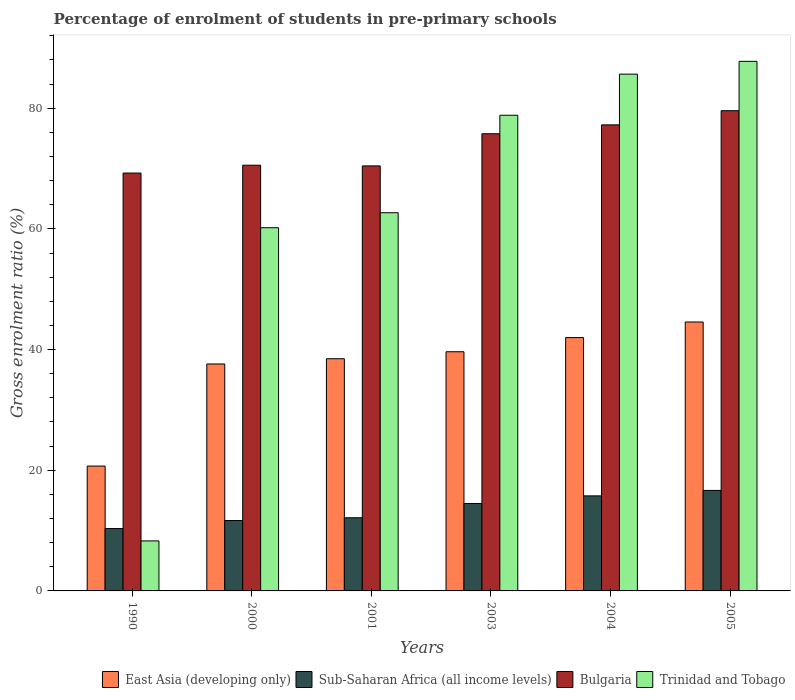How many different coloured bars are there?
Offer a terse response. 4. Are the number of bars on each tick of the X-axis equal?
Give a very brief answer. Yes. How many bars are there on the 3rd tick from the left?
Offer a terse response. 4. How many bars are there on the 3rd tick from the right?
Offer a terse response. 4. What is the label of the 4th group of bars from the left?
Make the answer very short. 2003. What is the percentage of students enrolled in pre-primary schools in Bulgaria in 2000?
Keep it short and to the point. 70.55. Across all years, what is the maximum percentage of students enrolled in pre-primary schools in East Asia (developing only)?
Give a very brief answer. 44.57. Across all years, what is the minimum percentage of students enrolled in pre-primary schools in East Asia (developing only)?
Your response must be concise. 20.69. In which year was the percentage of students enrolled in pre-primary schools in Bulgaria maximum?
Your answer should be very brief. 2005. In which year was the percentage of students enrolled in pre-primary schools in Bulgaria minimum?
Make the answer very short. 1990. What is the total percentage of students enrolled in pre-primary schools in East Asia (developing only) in the graph?
Keep it short and to the point. 222.98. What is the difference between the percentage of students enrolled in pre-primary schools in Sub-Saharan Africa (all income levels) in 1990 and that in 2000?
Give a very brief answer. -1.33. What is the difference between the percentage of students enrolled in pre-primary schools in East Asia (developing only) in 2005 and the percentage of students enrolled in pre-primary schools in Bulgaria in 2003?
Give a very brief answer. -31.2. What is the average percentage of students enrolled in pre-primary schools in Trinidad and Tobago per year?
Provide a short and direct response. 63.9. In the year 2003, what is the difference between the percentage of students enrolled in pre-primary schools in East Asia (developing only) and percentage of students enrolled in pre-primary schools in Trinidad and Tobago?
Offer a very short reply. -39.2. In how many years, is the percentage of students enrolled in pre-primary schools in Trinidad and Tobago greater than 36 %?
Your answer should be compact. 5. What is the ratio of the percentage of students enrolled in pre-primary schools in Sub-Saharan Africa (all income levels) in 1990 to that in 2001?
Keep it short and to the point. 0.85. Is the difference between the percentage of students enrolled in pre-primary schools in East Asia (developing only) in 1990 and 2003 greater than the difference between the percentage of students enrolled in pre-primary schools in Trinidad and Tobago in 1990 and 2003?
Provide a short and direct response. Yes. What is the difference between the highest and the second highest percentage of students enrolled in pre-primary schools in East Asia (developing only)?
Give a very brief answer. 2.58. What is the difference between the highest and the lowest percentage of students enrolled in pre-primary schools in Sub-Saharan Africa (all income levels)?
Provide a succinct answer. 6.32. In how many years, is the percentage of students enrolled in pre-primary schools in Bulgaria greater than the average percentage of students enrolled in pre-primary schools in Bulgaria taken over all years?
Keep it short and to the point. 3. Is it the case that in every year, the sum of the percentage of students enrolled in pre-primary schools in Trinidad and Tobago and percentage of students enrolled in pre-primary schools in East Asia (developing only) is greater than the sum of percentage of students enrolled in pre-primary schools in Bulgaria and percentage of students enrolled in pre-primary schools in Sub-Saharan Africa (all income levels)?
Make the answer very short. No. What does the 1st bar from the left in 2003 represents?
Give a very brief answer. East Asia (developing only). What does the 3rd bar from the right in 2005 represents?
Your answer should be very brief. Sub-Saharan Africa (all income levels). How many bars are there?
Your answer should be very brief. 24. Are all the bars in the graph horizontal?
Offer a very short reply. No. How many years are there in the graph?
Make the answer very short. 6. What is the difference between two consecutive major ticks on the Y-axis?
Give a very brief answer. 20. Are the values on the major ticks of Y-axis written in scientific E-notation?
Your answer should be compact. No. Where does the legend appear in the graph?
Provide a short and direct response. Bottom right. How many legend labels are there?
Make the answer very short. 4. What is the title of the graph?
Your answer should be compact. Percentage of enrolment of students in pre-primary schools. Does "Finland" appear as one of the legend labels in the graph?
Ensure brevity in your answer.  No. What is the Gross enrolment ratio (%) of East Asia (developing only) in 1990?
Give a very brief answer. 20.69. What is the Gross enrolment ratio (%) in Sub-Saharan Africa (all income levels) in 1990?
Ensure brevity in your answer.  10.34. What is the Gross enrolment ratio (%) in Bulgaria in 1990?
Ensure brevity in your answer.  69.25. What is the Gross enrolment ratio (%) of Trinidad and Tobago in 1990?
Offer a very short reply. 8.29. What is the Gross enrolment ratio (%) of East Asia (developing only) in 2000?
Keep it short and to the point. 37.61. What is the Gross enrolment ratio (%) of Sub-Saharan Africa (all income levels) in 2000?
Your response must be concise. 11.67. What is the Gross enrolment ratio (%) of Bulgaria in 2000?
Your answer should be compact. 70.55. What is the Gross enrolment ratio (%) of Trinidad and Tobago in 2000?
Give a very brief answer. 60.19. What is the Gross enrolment ratio (%) in East Asia (developing only) in 2001?
Offer a very short reply. 38.48. What is the Gross enrolment ratio (%) in Sub-Saharan Africa (all income levels) in 2001?
Keep it short and to the point. 12.13. What is the Gross enrolment ratio (%) of Bulgaria in 2001?
Keep it short and to the point. 70.44. What is the Gross enrolment ratio (%) of Trinidad and Tobago in 2001?
Provide a short and direct response. 62.68. What is the Gross enrolment ratio (%) of East Asia (developing only) in 2003?
Offer a terse response. 39.64. What is the Gross enrolment ratio (%) of Sub-Saharan Africa (all income levels) in 2003?
Provide a succinct answer. 14.49. What is the Gross enrolment ratio (%) in Bulgaria in 2003?
Your answer should be very brief. 75.77. What is the Gross enrolment ratio (%) in Trinidad and Tobago in 2003?
Provide a succinct answer. 78.84. What is the Gross enrolment ratio (%) of East Asia (developing only) in 2004?
Provide a short and direct response. 41.99. What is the Gross enrolment ratio (%) of Sub-Saharan Africa (all income levels) in 2004?
Provide a short and direct response. 15.75. What is the Gross enrolment ratio (%) of Bulgaria in 2004?
Offer a very short reply. 77.24. What is the Gross enrolment ratio (%) in Trinidad and Tobago in 2004?
Provide a short and direct response. 85.65. What is the Gross enrolment ratio (%) of East Asia (developing only) in 2005?
Your answer should be very brief. 44.57. What is the Gross enrolment ratio (%) in Sub-Saharan Africa (all income levels) in 2005?
Your response must be concise. 16.66. What is the Gross enrolment ratio (%) in Bulgaria in 2005?
Ensure brevity in your answer.  79.59. What is the Gross enrolment ratio (%) in Trinidad and Tobago in 2005?
Keep it short and to the point. 87.77. Across all years, what is the maximum Gross enrolment ratio (%) in East Asia (developing only)?
Make the answer very short. 44.57. Across all years, what is the maximum Gross enrolment ratio (%) of Sub-Saharan Africa (all income levels)?
Keep it short and to the point. 16.66. Across all years, what is the maximum Gross enrolment ratio (%) of Bulgaria?
Offer a terse response. 79.59. Across all years, what is the maximum Gross enrolment ratio (%) of Trinidad and Tobago?
Ensure brevity in your answer.  87.77. Across all years, what is the minimum Gross enrolment ratio (%) in East Asia (developing only)?
Offer a very short reply. 20.69. Across all years, what is the minimum Gross enrolment ratio (%) of Sub-Saharan Africa (all income levels)?
Keep it short and to the point. 10.34. Across all years, what is the minimum Gross enrolment ratio (%) of Bulgaria?
Offer a very short reply. 69.25. Across all years, what is the minimum Gross enrolment ratio (%) in Trinidad and Tobago?
Your answer should be very brief. 8.29. What is the total Gross enrolment ratio (%) in East Asia (developing only) in the graph?
Keep it short and to the point. 222.98. What is the total Gross enrolment ratio (%) in Sub-Saharan Africa (all income levels) in the graph?
Provide a succinct answer. 81.02. What is the total Gross enrolment ratio (%) of Bulgaria in the graph?
Make the answer very short. 442.85. What is the total Gross enrolment ratio (%) in Trinidad and Tobago in the graph?
Ensure brevity in your answer.  383.41. What is the difference between the Gross enrolment ratio (%) of East Asia (developing only) in 1990 and that in 2000?
Offer a very short reply. -16.92. What is the difference between the Gross enrolment ratio (%) of Sub-Saharan Africa (all income levels) in 1990 and that in 2000?
Provide a succinct answer. -1.33. What is the difference between the Gross enrolment ratio (%) in Trinidad and Tobago in 1990 and that in 2000?
Ensure brevity in your answer.  -51.91. What is the difference between the Gross enrolment ratio (%) in East Asia (developing only) in 1990 and that in 2001?
Provide a short and direct response. -17.79. What is the difference between the Gross enrolment ratio (%) of Sub-Saharan Africa (all income levels) in 1990 and that in 2001?
Provide a succinct answer. -1.79. What is the difference between the Gross enrolment ratio (%) of Bulgaria in 1990 and that in 2001?
Offer a terse response. -1.19. What is the difference between the Gross enrolment ratio (%) in Trinidad and Tobago in 1990 and that in 2001?
Ensure brevity in your answer.  -54.39. What is the difference between the Gross enrolment ratio (%) of East Asia (developing only) in 1990 and that in 2003?
Provide a succinct answer. -18.95. What is the difference between the Gross enrolment ratio (%) in Sub-Saharan Africa (all income levels) in 1990 and that in 2003?
Ensure brevity in your answer.  -4.15. What is the difference between the Gross enrolment ratio (%) of Bulgaria in 1990 and that in 2003?
Make the answer very short. -6.52. What is the difference between the Gross enrolment ratio (%) of Trinidad and Tobago in 1990 and that in 2003?
Keep it short and to the point. -70.55. What is the difference between the Gross enrolment ratio (%) of East Asia (developing only) in 1990 and that in 2004?
Provide a short and direct response. -21.29. What is the difference between the Gross enrolment ratio (%) of Sub-Saharan Africa (all income levels) in 1990 and that in 2004?
Your response must be concise. -5.42. What is the difference between the Gross enrolment ratio (%) in Bulgaria in 1990 and that in 2004?
Your response must be concise. -7.99. What is the difference between the Gross enrolment ratio (%) in Trinidad and Tobago in 1990 and that in 2004?
Provide a short and direct response. -77.36. What is the difference between the Gross enrolment ratio (%) of East Asia (developing only) in 1990 and that in 2005?
Your answer should be compact. -23.88. What is the difference between the Gross enrolment ratio (%) of Sub-Saharan Africa (all income levels) in 1990 and that in 2005?
Provide a succinct answer. -6.32. What is the difference between the Gross enrolment ratio (%) of Bulgaria in 1990 and that in 2005?
Provide a short and direct response. -10.34. What is the difference between the Gross enrolment ratio (%) of Trinidad and Tobago in 1990 and that in 2005?
Make the answer very short. -79.48. What is the difference between the Gross enrolment ratio (%) in East Asia (developing only) in 2000 and that in 2001?
Offer a terse response. -0.87. What is the difference between the Gross enrolment ratio (%) of Sub-Saharan Africa (all income levels) in 2000 and that in 2001?
Keep it short and to the point. -0.46. What is the difference between the Gross enrolment ratio (%) of Bulgaria in 2000 and that in 2001?
Provide a short and direct response. 0.11. What is the difference between the Gross enrolment ratio (%) in Trinidad and Tobago in 2000 and that in 2001?
Your response must be concise. -2.48. What is the difference between the Gross enrolment ratio (%) of East Asia (developing only) in 2000 and that in 2003?
Your answer should be compact. -2.03. What is the difference between the Gross enrolment ratio (%) in Sub-Saharan Africa (all income levels) in 2000 and that in 2003?
Give a very brief answer. -2.82. What is the difference between the Gross enrolment ratio (%) in Bulgaria in 2000 and that in 2003?
Your answer should be compact. -5.22. What is the difference between the Gross enrolment ratio (%) of Trinidad and Tobago in 2000 and that in 2003?
Offer a terse response. -18.64. What is the difference between the Gross enrolment ratio (%) of East Asia (developing only) in 2000 and that in 2004?
Your answer should be compact. -4.37. What is the difference between the Gross enrolment ratio (%) of Sub-Saharan Africa (all income levels) in 2000 and that in 2004?
Give a very brief answer. -4.09. What is the difference between the Gross enrolment ratio (%) of Bulgaria in 2000 and that in 2004?
Make the answer very short. -6.69. What is the difference between the Gross enrolment ratio (%) in Trinidad and Tobago in 2000 and that in 2004?
Offer a terse response. -25.45. What is the difference between the Gross enrolment ratio (%) in East Asia (developing only) in 2000 and that in 2005?
Provide a succinct answer. -6.96. What is the difference between the Gross enrolment ratio (%) in Sub-Saharan Africa (all income levels) in 2000 and that in 2005?
Your response must be concise. -4.99. What is the difference between the Gross enrolment ratio (%) of Bulgaria in 2000 and that in 2005?
Your answer should be compact. -9.04. What is the difference between the Gross enrolment ratio (%) in Trinidad and Tobago in 2000 and that in 2005?
Your answer should be compact. -27.57. What is the difference between the Gross enrolment ratio (%) of East Asia (developing only) in 2001 and that in 2003?
Ensure brevity in your answer.  -1.16. What is the difference between the Gross enrolment ratio (%) of Sub-Saharan Africa (all income levels) in 2001 and that in 2003?
Offer a very short reply. -2.36. What is the difference between the Gross enrolment ratio (%) of Bulgaria in 2001 and that in 2003?
Your answer should be compact. -5.33. What is the difference between the Gross enrolment ratio (%) of Trinidad and Tobago in 2001 and that in 2003?
Provide a short and direct response. -16.16. What is the difference between the Gross enrolment ratio (%) of East Asia (developing only) in 2001 and that in 2004?
Your answer should be compact. -3.5. What is the difference between the Gross enrolment ratio (%) in Sub-Saharan Africa (all income levels) in 2001 and that in 2004?
Offer a very short reply. -3.63. What is the difference between the Gross enrolment ratio (%) of Bulgaria in 2001 and that in 2004?
Ensure brevity in your answer.  -6.8. What is the difference between the Gross enrolment ratio (%) of Trinidad and Tobago in 2001 and that in 2004?
Offer a terse response. -22.97. What is the difference between the Gross enrolment ratio (%) of East Asia (developing only) in 2001 and that in 2005?
Provide a succinct answer. -6.09. What is the difference between the Gross enrolment ratio (%) in Sub-Saharan Africa (all income levels) in 2001 and that in 2005?
Ensure brevity in your answer.  -4.53. What is the difference between the Gross enrolment ratio (%) of Bulgaria in 2001 and that in 2005?
Keep it short and to the point. -9.15. What is the difference between the Gross enrolment ratio (%) in Trinidad and Tobago in 2001 and that in 2005?
Offer a terse response. -25.09. What is the difference between the Gross enrolment ratio (%) in East Asia (developing only) in 2003 and that in 2004?
Make the answer very short. -2.35. What is the difference between the Gross enrolment ratio (%) of Sub-Saharan Africa (all income levels) in 2003 and that in 2004?
Provide a succinct answer. -1.27. What is the difference between the Gross enrolment ratio (%) in Bulgaria in 2003 and that in 2004?
Give a very brief answer. -1.47. What is the difference between the Gross enrolment ratio (%) of Trinidad and Tobago in 2003 and that in 2004?
Your answer should be compact. -6.81. What is the difference between the Gross enrolment ratio (%) of East Asia (developing only) in 2003 and that in 2005?
Provide a short and direct response. -4.93. What is the difference between the Gross enrolment ratio (%) in Sub-Saharan Africa (all income levels) in 2003 and that in 2005?
Make the answer very short. -2.17. What is the difference between the Gross enrolment ratio (%) of Bulgaria in 2003 and that in 2005?
Provide a short and direct response. -3.82. What is the difference between the Gross enrolment ratio (%) of Trinidad and Tobago in 2003 and that in 2005?
Offer a very short reply. -8.93. What is the difference between the Gross enrolment ratio (%) in East Asia (developing only) in 2004 and that in 2005?
Keep it short and to the point. -2.58. What is the difference between the Gross enrolment ratio (%) in Sub-Saharan Africa (all income levels) in 2004 and that in 2005?
Provide a short and direct response. -0.9. What is the difference between the Gross enrolment ratio (%) of Bulgaria in 2004 and that in 2005?
Give a very brief answer. -2.35. What is the difference between the Gross enrolment ratio (%) in Trinidad and Tobago in 2004 and that in 2005?
Ensure brevity in your answer.  -2.12. What is the difference between the Gross enrolment ratio (%) in East Asia (developing only) in 1990 and the Gross enrolment ratio (%) in Sub-Saharan Africa (all income levels) in 2000?
Provide a succinct answer. 9.03. What is the difference between the Gross enrolment ratio (%) of East Asia (developing only) in 1990 and the Gross enrolment ratio (%) of Bulgaria in 2000?
Your response must be concise. -49.86. What is the difference between the Gross enrolment ratio (%) of East Asia (developing only) in 1990 and the Gross enrolment ratio (%) of Trinidad and Tobago in 2000?
Make the answer very short. -39.5. What is the difference between the Gross enrolment ratio (%) of Sub-Saharan Africa (all income levels) in 1990 and the Gross enrolment ratio (%) of Bulgaria in 2000?
Make the answer very short. -60.22. What is the difference between the Gross enrolment ratio (%) of Sub-Saharan Africa (all income levels) in 1990 and the Gross enrolment ratio (%) of Trinidad and Tobago in 2000?
Your response must be concise. -49.86. What is the difference between the Gross enrolment ratio (%) of Bulgaria in 1990 and the Gross enrolment ratio (%) of Trinidad and Tobago in 2000?
Offer a very short reply. 9.06. What is the difference between the Gross enrolment ratio (%) of East Asia (developing only) in 1990 and the Gross enrolment ratio (%) of Sub-Saharan Africa (all income levels) in 2001?
Make the answer very short. 8.57. What is the difference between the Gross enrolment ratio (%) in East Asia (developing only) in 1990 and the Gross enrolment ratio (%) in Bulgaria in 2001?
Your response must be concise. -49.75. What is the difference between the Gross enrolment ratio (%) of East Asia (developing only) in 1990 and the Gross enrolment ratio (%) of Trinidad and Tobago in 2001?
Keep it short and to the point. -41.99. What is the difference between the Gross enrolment ratio (%) of Sub-Saharan Africa (all income levels) in 1990 and the Gross enrolment ratio (%) of Bulgaria in 2001?
Your answer should be compact. -60.1. What is the difference between the Gross enrolment ratio (%) in Sub-Saharan Africa (all income levels) in 1990 and the Gross enrolment ratio (%) in Trinidad and Tobago in 2001?
Offer a terse response. -52.34. What is the difference between the Gross enrolment ratio (%) of Bulgaria in 1990 and the Gross enrolment ratio (%) of Trinidad and Tobago in 2001?
Make the answer very short. 6.57. What is the difference between the Gross enrolment ratio (%) in East Asia (developing only) in 1990 and the Gross enrolment ratio (%) in Sub-Saharan Africa (all income levels) in 2003?
Offer a terse response. 6.21. What is the difference between the Gross enrolment ratio (%) in East Asia (developing only) in 1990 and the Gross enrolment ratio (%) in Bulgaria in 2003?
Keep it short and to the point. -55.08. What is the difference between the Gross enrolment ratio (%) in East Asia (developing only) in 1990 and the Gross enrolment ratio (%) in Trinidad and Tobago in 2003?
Your response must be concise. -58.14. What is the difference between the Gross enrolment ratio (%) of Sub-Saharan Africa (all income levels) in 1990 and the Gross enrolment ratio (%) of Bulgaria in 2003?
Ensure brevity in your answer.  -65.43. What is the difference between the Gross enrolment ratio (%) in Sub-Saharan Africa (all income levels) in 1990 and the Gross enrolment ratio (%) in Trinidad and Tobago in 2003?
Your answer should be compact. -68.5. What is the difference between the Gross enrolment ratio (%) in Bulgaria in 1990 and the Gross enrolment ratio (%) in Trinidad and Tobago in 2003?
Your answer should be very brief. -9.58. What is the difference between the Gross enrolment ratio (%) of East Asia (developing only) in 1990 and the Gross enrolment ratio (%) of Sub-Saharan Africa (all income levels) in 2004?
Keep it short and to the point. 4.94. What is the difference between the Gross enrolment ratio (%) in East Asia (developing only) in 1990 and the Gross enrolment ratio (%) in Bulgaria in 2004?
Your response must be concise. -56.55. What is the difference between the Gross enrolment ratio (%) in East Asia (developing only) in 1990 and the Gross enrolment ratio (%) in Trinidad and Tobago in 2004?
Give a very brief answer. -64.96. What is the difference between the Gross enrolment ratio (%) of Sub-Saharan Africa (all income levels) in 1990 and the Gross enrolment ratio (%) of Bulgaria in 2004?
Provide a succinct answer. -66.91. What is the difference between the Gross enrolment ratio (%) of Sub-Saharan Africa (all income levels) in 1990 and the Gross enrolment ratio (%) of Trinidad and Tobago in 2004?
Make the answer very short. -75.31. What is the difference between the Gross enrolment ratio (%) in Bulgaria in 1990 and the Gross enrolment ratio (%) in Trinidad and Tobago in 2004?
Offer a very short reply. -16.4. What is the difference between the Gross enrolment ratio (%) in East Asia (developing only) in 1990 and the Gross enrolment ratio (%) in Sub-Saharan Africa (all income levels) in 2005?
Offer a terse response. 4.04. What is the difference between the Gross enrolment ratio (%) in East Asia (developing only) in 1990 and the Gross enrolment ratio (%) in Bulgaria in 2005?
Give a very brief answer. -58.9. What is the difference between the Gross enrolment ratio (%) in East Asia (developing only) in 1990 and the Gross enrolment ratio (%) in Trinidad and Tobago in 2005?
Keep it short and to the point. -67.08. What is the difference between the Gross enrolment ratio (%) in Sub-Saharan Africa (all income levels) in 1990 and the Gross enrolment ratio (%) in Bulgaria in 2005?
Give a very brief answer. -69.25. What is the difference between the Gross enrolment ratio (%) in Sub-Saharan Africa (all income levels) in 1990 and the Gross enrolment ratio (%) in Trinidad and Tobago in 2005?
Provide a short and direct response. -77.43. What is the difference between the Gross enrolment ratio (%) in Bulgaria in 1990 and the Gross enrolment ratio (%) in Trinidad and Tobago in 2005?
Your answer should be compact. -18.51. What is the difference between the Gross enrolment ratio (%) in East Asia (developing only) in 2000 and the Gross enrolment ratio (%) in Sub-Saharan Africa (all income levels) in 2001?
Keep it short and to the point. 25.49. What is the difference between the Gross enrolment ratio (%) in East Asia (developing only) in 2000 and the Gross enrolment ratio (%) in Bulgaria in 2001?
Provide a succinct answer. -32.83. What is the difference between the Gross enrolment ratio (%) of East Asia (developing only) in 2000 and the Gross enrolment ratio (%) of Trinidad and Tobago in 2001?
Keep it short and to the point. -25.07. What is the difference between the Gross enrolment ratio (%) in Sub-Saharan Africa (all income levels) in 2000 and the Gross enrolment ratio (%) in Bulgaria in 2001?
Make the answer very short. -58.77. What is the difference between the Gross enrolment ratio (%) in Sub-Saharan Africa (all income levels) in 2000 and the Gross enrolment ratio (%) in Trinidad and Tobago in 2001?
Give a very brief answer. -51.01. What is the difference between the Gross enrolment ratio (%) in Bulgaria in 2000 and the Gross enrolment ratio (%) in Trinidad and Tobago in 2001?
Your answer should be very brief. 7.87. What is the difference between the Gross enrolment ratio (%) of East Asia (developing only) in 2000 and the Gross enrolment ratio (%) of Sub-Saharan Africa (all income levels) in 2003?
Make the answer very short. 23.13. What is the difference between the Gross enrolment ratio (%) of East Asia (developing only) in 2000 and the Gross enrolment ratio (%) of Bulgaria in 2003?
Ensure brevity in your answer.  -38.16. What is the difference between the Gross enrolment ratio (%) in East Asia (developing only) in 2000 and the Gross enrolment ratio (%) in Trinidad and Tobago in 2003?
Make the answer very short. -41.22. What is the difference between the Gross enrolment ratio (%) of Sub-Saharan Africa (all income levels) in 2000 and the Gross enrolment ratio (%) of Bulgaria in 2003?
Ensure brevity in your answer.  -64.1. What is the difference between the Gross enrolment ratio (%) of Sub-Saharan Africa (all income levels) in 2000 and the Gross enrolment ratio (%) of Trinidad and Tobago in 2003?
Offer a terse response. -67.17. What is the difference between the Gross enrolment ratio (%) in Bulgaria in 2000 and the Gross enrolment ratio (%) in Trinidad and Tobago in 2003?
Your response must be concise. -8.28. What is the difference between the Gross enrolment ratio (%) of East Asia (developing only) in 2000 and the Gross enrolment ratio (%) of Sub-Saharan Africa (all income levels) in 2004?
Your response must be concise. 21.86. What is the difference between the Gross enrolment ratio (%) of East Asia (developing only) in 2000 and the Gross enrolment ratio (%) of Bulgaria in 2004?
Your response must be concise. -39.63. What is the difference between the Gross enrolment ratio (%) in East Asia (developing only) in 2000 and the Gross enrolment ratio (%) in Trinidad and Tobago in 2004?
Provide a succinct answer. -48.04. What is the difference between the Gross enrolment ratio (%) of Sub-Saharan Africa (all income levels) in 2000 and the Gross enrolment ratio (%) of Bulgaria in 2004?
Your answer should be very brief. -65.57. What is the difference between the Gross enrolment ratio (%) of Sub-Saharan Africa (all income levels) in 2000 and the Gross enrolment ratio (%) of Trinidad and Tobago in 2004?
Keep it short and to the point. -73.98. What is the difference between the Gross enrolment ratio (%) in Bulgaria in 2000 and the Gross enrolment ratio (%) in Trinidad and Tobago in 2004?
Your answer should be compact. -15.1. What is the difference between the Gross enrolment ratio (%) of East Asia (developing only) in 2000 and the Gross enrolment ratio (%) of Sub-Saharan Africa (all income levels) in 2005?
Ensure brevity in your answer.  20.96. What is the difference between the Gross enrolment ratio (%) in East Asia (developing only) in 2000 and the Gross enrolment ratio (%) in Bulgaria in 2005?
Ensure brevity in your answer.  -41.98. What is the difference between the Gross enrolment ratio (%) of East Asia (developing only) in 2000 and the Gross enrolment ratio (%) of Trinidad and Tobago in 2005?
Your answer should be compact. -50.16. What is the difference between the Gross enrolment ratio (%) of Sub-Saharan Africa (all income levels) in 2000 and the Gross enrolment ratio (%) of Bulgaria in 2005?
Give a very brief answer. -67.92. What is the difference between the Gross enrolment ratio (%) in Sub-Saharan Africa (all income levels) in 2000 and the Gross enrolment ratio (%) in Trinidad and Tobago in 2005?
Provide a short and direct response. -76.1. What is the difference between the Gross enrolment ratio (%) in Bulgaria in 2000 and the Gross enrolment ratio (%) in Trinidad and Tobago in 2005?
Give a very brief answer. -17.21. What is the difference between the Gross enrolment ratio (%) in East Asia (developing only) in 2001 and the Gross enrolment ratio (%) in Sub-Saharan Africa (all income levels) in 2003?
Offer a very short reply. 24. What is the difference between the Gross enrolment ratio (%) of East Asia (developing only) in 2001 and the Gross enrolment ratio (%) of Bulgaria in 2003?
Offer a very short reply. -37.29. What is the difference between the Gross enrolment ratio (%) of East Asia (developing only) in 2001 and the Gross enrolment ratio (%) of Trinidad and Tobago in 2003?
Give a very brief answer. -40.35. What is the difference between the Gross enrolment ratio (%) in Sub-Saharan Africa (all income levels) in 2001 and the Gross enrolment ratio (%) in Bulgaria in 2003?
Your answer should be compact. -63.64. What is the difference between the Gross enrolment ratio (%) in Sub-Saharan Africa (all income levels) in 2001 and the Gross enrolment ratio (%) in Trinidad and Tobago in 2003?
Your answer should be very brief. -66.71. What is the difference between the Gross enrolment ratio (%) in Bulgaria in 2001 and the Gross enrolment ratio (%) in Trinidad and Tobago in 2003?
Offer a terse response. -8.4. What is the difference between the Gross enrolment ratio (%) of East Asia (developing only) in 2001 and the Gross enrolment ratio (%) of Sub-Saharan Africa (all income levels) in 2004?
Give a very brief answer. 22.73. What is the difference between the Gross enrolment ratio (%) of East Asia (developing only) in 2001 and the Gross enrolment ratio (%) of Bulgaria in 2004?
Offer a terse response. -38.76. What is the difference between the Gross enrolment ratio (%) in East Asia (developing only) in 2001 and the Gross enrolment ratio (%) in Trinidad and Tobago in 2004?
Keep it short and to the point. -47.17. What is the difference between the Gross enrolment ratio (%) of Sub-Saharan Africa (all income levels) in 2001 and the Gross enrolment ratio (%) of Bulgaria in 2004?
Your answer should be compact. -65.12. What is the difference between the Gross enrolment ratio (%) in Sub-Saharan Africa (all income levels) in 2001 and the Gross enrolment ratio (%) in Trinidad and Tobago in 2004?
Give a very brief answer. -73.52. What is the difference between the Gross enrolment ratio (%) in Bulgaria in 2001 and the Gross enrolment ratio (%) in Trinidad and Tobago in 2004?
Give a very brief answer. -15.21. What is the difference between the Gross enrolment ratio (%) in East Asia (developing only) in 2001 and the Gross enrolment ratio (%) in Sub-Saharan Africa (all income levels) in 2005?
Give a very brief answer. 21.83. What is the difference between the Gross enrolment ratio (%) in East Asia (developing only) in 2001 and the Gross enrolment ratio (%) in Bulgaria in 2005?
Provide a succinct answer. -41.11. What is the difference between the Gross enrolment ratio (%) of East Asia (developing only) in 2001 and the Gross enrolment ratio (%) of Trinidad and Tobago in 2005?
Give a very brief answer. -49.29. What is the difference between the Gross enrolment ratio (%) in Sub-Saharan Africa (all income levels) in 2001 and the Gross enrolment ratio (%) in Bulgaria in 2005?
Your answer should be compact. -67.46. What is the difference between the Gross enrolment ratio (%) in Sub-Saharan Africa (all income levels) in 2001 and the Gross enrolment ratio (%) in Trinidad and Tobago in 2005?
Make the answer very short. -75.64. What is the difference between the Gross enrolment ratio (%) in Bulgaria in 2001 and the Gross enrolment ratio (%) in Trinidad and Tobago in 2005?
Your answer should be compact. -17.33. What is the difference between the Gross enrolment ratio (%) in East Asia (developing only) in 2003 and the Gross enrolment ratio (%) in Sub-Saharan Africa (all income levels) in 2004?
Your response must be concise. 23.89. What is the difference between the Gross enrolment ratio (%) in East Asia (developing only) in 2003 and the Gross enrolment ratio (%) in Bulgaria in 2004?
Your answer should be very brief. -37.6. What is the difference between the Gross enrolment ratio (%) of East Asia (developing only) in 2003 and the Gross enrolment ratio (%) of Trinidad and Tobago in 2004?
Provide a short and direct response. -46.01. What is the difference between the Gross enrolment ratio (%) of Sub-Saharan Africa (all income levels) in 2003 and the Gross enrolment ratio (%) of Bulgaria in 2004?
Your answer should be compact. -62.76. What is the difference between the Gross enrolment ratio (%) of Sub-Saharan Africa (all income levels) in 2003 and the Gross enrolment ratio (%) of Trinidad and Tobago in 2004?
Give a very brief answer. -71.16. What is the difference between the Gross enrolment ratio (%) in Bulgaria in 2003 and the Gross enrolment ratio (%) in Trinidad and Tobago in 2004?
Your answer should be compact. -9.88. What is the difference between the Gross enrolment ratio (%) of East Asia (developing only) in 2003 and the Gross enrolment ratio (%) of Sub-Saharan Africa (all income levels) in 2005?
Offer a very short reply. 22.98. What is the difference between the Gross enrolment ratio (%) of East Asia (developing only) in 2003 and the Gross enrolment ratio (%) of Bulgaria in 2005?
Your answer should be compact. -39.95. What is the difference between the Gross enrolment ratio (%) in East Asia (developing only) in 2003 and the Gross enrolment ratio (%) in Trinidad and Tobago in 2005?
Your answer should be compact. -48.13. What is the difference between the Gross enrolment ratio (%) of Sub-Saharan Africa (all income levels) in 2003 and the Gross enrolment ratio (%) of Bulgaria in 2005?
Provide a short and direct response. -65.1. What is the difference between the Gross enrolment ratio (%) of Sub-Saharan Africa (all income levels) in 2003 and the Gross enrolment ratio (%) of Trinidad and Tobago in 2005?
Provide a succinct answer. -73.28. What is the difference between the Gross enrolment ratio (%) in Bulgaria in 2003 and the Gross enrolment ratio (%) in Trinidad and Tobago in 2005?
Make the answer very short. -12. What is the difference between the Gross enrolment ratio (%) in East Asia (developing only) in 2004 and the Gross enrolment ratio (%) in Sub-Saharan Africa (all income levels) in 2005?
Provide a short and direct response. 25.33. What is the difference between the Gross enrolment ratio (%) in East Asia (developing only) in 2004 and the Gross enrolment ratio (%) in Bulgaria in 2005?
Offer a terse response. -37.6. What is the difference between the Gross enrolment ratio (%) of East Asia (developing only) in 2004 and the Gross enrolment ratio (%) of Trinidad and Tobago in 2005?
Your response must be concise. -45.78. What is the difference between the Gross enrolment ratio (%) in Sub-Saharan Africa (all income levels) in 2004 and the Gross enrolment ratio (%) in Bulgaria in 2005?
Offer a very short reply. -63.84. What is the difference between the Gross enrolment ratio (%) in Sub-Saharan Africa (all income levels) in 2004 and the Gross enrolment ratio (%) in Trinidad and Tobago in 2005?
Keep it short and to the point. -72.01. What is the difference between the Gross enrolment ratio (%) in Bulgaria in 2004 and the Gross enrolment ratio (%) in Trinidad and Tobago in 2005?
Your answer should be very brief. -10.53. What is the average Gross enrolment ratio (%) of East Asia (developing only) per year?
Ensure brevity in your answer.  37.16. What is the average Gross enrolment ratio (%) of Sub-Saharan Africa (all income levels) per year?
Your answer should be very brief. 13.5. What is the average Gross enrolment ratio (%) of Bulgaria per year?
Provide a succinct answer. 73.81. What is the average Gross enrolment ratio (%) of Trinidad and Tobago per year?
Ensure brevity in your answer.  63.9. In the year 1990, what is the difference between the Gross enrolment ratio (%) of East Asia (developing only) and Gross enrolment ratio (%) of Sub-Saharan Africa (all income levels)?
Ensure brevity in your answer.  10.36. In the year 1990, what is the difference between the Gross enrolment ratio (%) in East Asia (developing only) and Gross enrolment ratio (%) in Bulgaria?
Ensure brevity in your answer.  -48.56. In the year 1990, what is the difference between the Gross enrolment ratio (%) of East Asia (developing only) and Gross enrolment ratio (%) of Trinidad and Tobago?
Offer a terse response. 12.4. In the year 1990, what is the difference between the Gross enrolment ratio (%) in Sub-Saharan Africa (all income levels) and Gross enrolment ratio (%) in Bulgaria?
Your answer should be very brief. -58.92. In the year 1990, what is the difference between the Gross enrolment ratio (%) of Sub-Saharan Africa (all income levels) and Gross enrolment ratio (%) of Trinidad and Tobago?
Offer a terse response. 2.05. In the year 1990, what is the difference between the Gross enrolment ratio (%) of Bulgaria and Gross enrolment ratio (%) of Trinidad and Tobago?
Your answer should be very brief. 60.97. In the year 2000, what is the difference between the Gross enrolment ratio (%) of East Asia (developing only) and Gross enrolment ratio (%) of Sub-Saharan Africa (all income levels)?
Your answer should be compact. 25.95. In the year 2000, what is the difference between the Gross enrolment ratio (%) of East Asia (developing only) and Gross enrolment ratio (%) of Bulgaria?
Your answer should be very brief. -32.94. In the year 2000, what is the difference between the Gross enrolment ratio (%) in East Asia (developing only) and Gross enrolment ratio (%) in Trinidad and Tobago?
Your answer should be very brief. -22.58. In the year 2000, what is the difference between the Gross enrolment ratio (%) in Sub-Saharan Africa (all income levels) and Gross enrolment ratio (%) in Bulgaria?
Provide a short and direct response. -58.89. In the year 2000, what is the difference between the Gross enrolment ratio (%) of Sub-Saharan Africa (all income levels) and Gross enrolment ratio (%) of Trinidad and Tobago?
Make the answer very short. -48.53. In the year 2000, what is the difference between the Gross enrolment ratio (%) in Bulgaria and Gross enrolment ratio (%) in Trinidad and Tobago?
Offer a very short reply. 10.36. In the year 2001, what is the difference between the Gross enrolment ratio (%) of East Asia (developing only) and Gross enrolment ratio (%) of Sub-Saharan Africa (all income levels)?
Provide a succinct answer. 26.36. In the year 2001, what is the difference between the Gross enrolment ratio (%) in East Asia (developing only) and Gross enrolment ratio (%) in Bulgaria?
Keep it short and to the point. -31.96. In the year 2001, what is the difference between the Gross enrolment ratio (%) in East Asia (developing only) and Gross enrolment ratio (%) in Trinidad and Tobago?
Your answer should be compact. -24.2. In the year 2001, what is the difference between the Gross enrolment ratio (%) in Sub-Saharan Africa (all income levels) and Gross enrolment ratio (%) in Bulgaria?
Provide a succinct answer. -58.31. In the year 2001, what is the difference between the Gross enrolment ratio (%) in Sub-Saharan Africa (all income levels) and Gross enrolment ratio (%) in Trinidad and Tobago?
Offer a terse response. -50.55. In the year 2001, what is the difference between the Gross enrolment ratio (%) of Bulgaria and Gross enrolment ratio (%) of Trinidad and Tobago?
Provide a succinct answer. 7.76. In the year 2003, what is the difference between the Gross enrolment ratio (%) in East Asia (developing only) and Gross enrolment ratio (%) in Sub-Saharan Africa (all income levels)?
Give a very brief answer. 25.15. In the year 2003, what is the difference between the Gross enrolment ratio (%) of East Asia (developing only) and Gross enrolment ratio (%) of Bulgaria?
Your answer should be compact. -36.13. In the year 2003, what is the difference between the Gross enrolment ratio (%) in East Asia (developing only) and Gross enrolment ratio (%) in Trinidad and Tobago?
Your answer should be compact. -39.2. In the year 2003, what is the difference between the Gross enrolment ratio (%) in Sub-Saharan Africa (all income levels) and Gross enrolment ratio (%) in Bulgaria?
Keep it short and to the point. -61.28. In the year 2003, what is the difference between the Gross enrolment ratio (%) of Sub-Saharan Africa (all income levels) and Gross enrolment ratio (%) of Trinidad and Tobago?
Your response must be concise. -64.35. In the year 2003, what is the difference between the Gross enrolment ratio (%) of Bulgaria and Gross enrolment ratio (%) of Trinidad and Tobago?
Provide a short and direct response. -3.07. In the year 2004, what is the difference between the Gross enrolment ratio (%) in East Asia (developing only) and Gross enrolment ratio (%) in Sub-Saharan Africa (all income levels)?
Your answer should be very brief. 26.23. In the year 2004, what is the difference between the Gross enrolment ratio (%) in East Asia (developing only) and Gross enrolment ratio (%) in Bulgaria?
Give a very brief answer. -35.26. In the year 2004, what is the difference between the Gross enrolment ratio (%) in East Asia (developing only) and Gross enrolment ratio (%) in Trinidad and Tobago?
Your answer should be compact. -43.66. In the year 2004, what is the difference between the Gross enrolment ratio (%) of Sub-Saharan Africa (all income levels) and Gross enrolment ratio (%) of Bulgaria?
Offer a very short reply. -61.49. In the year 2004, what is the difference between the Gross enrolment ratio (%) in Sub-Saharan Africa (all income levels) and Gross enrolment ratio (%) in Trinidad and Tobago?
Your answer should be very brief. -69.89. In the year 2004, what is the difference between the Gross enrolment ratio (%) of Bulgaria and Gross enrolment ratio (%) of Trinidad and Tobago?
Provide a succinct answer. -8.41. In the year 2005, what is the difference between the Gross enrolment ratio (%) in East Asia (developing only) and Gross enrolment ratio (%) in Sub-Saharan Africa (all income levels)?
Provide a short and direct response. 27.91. In the year 2005, what is the difference between the Gross enrolment ratio (%) of East Asia (developing only) and Gross enrolment ratio (%) of Bulgaria?
Keep it short and to the point. -35.02. In the year 2005, what is the difference between the Gross enrolment ratio (%) of East Asia (developing only) and Gross enrolment ratio (%) of Trinidad and Tobago?
Offer a terse response. -43.2. In the year 2005, what is the difference between the Gross enrolment ratio (%) of Sub-Saharan Africa (all income levels) and Gross enrolment ratio (%) of Bulgaria?
Your answer should be very brief. -62.93. In the year 2005, what is the difference between the Gross enrolment ratio (%) of Sub-Saharan Africa (all income levels) and Gross enrolment ratio (%) of Trinidad and Tobago?
Provide a short and direct response. -71.11. In the year 2005, what is the difference between the Gross enrolment ratio (%) of Bulgaria and Gross enrolment ratio (%) of Trinidad and Tobago?
Offer a very short reply. -8.18. What is the ratio of the Gross enrolment ratio (%) of East Asia (developing only) in 1990 to that in 2000?
Keep it short and to the point. 0.55. What is the ratio of the Gross enrolment ratio (%) in Sub-Saharan Africa (all income levels) in 1990 to that in 2000?
Make the answer very short. 0.89. What is the ratio of the Gross enrolment ratio (%) of Bulgaria in 1990 to that in 2000?
Provide a short and direct response. 0.98. What is the ratio of the Gross enrolment ratio (%) of Trinidad and Tobago in 1990 to that in 2000?
Keep it short and to the point. 0.14. What is the ratio of the Gross enrolment ratio (%) of East Asia (developing only) in 1990 to that in 2001?
Your answer should be compact. 0.54. What is the ratio of the Gross enrolment ratio (%) of Sub-Saharan Africa (all income levels) in 1990 to that in 2001?
Give a very brief answer. 0.85. What is the ratio of the Gross enrolment ratio (%) in Bulgaria in 1990 to that in 2001?
Make the answer very short. 0.98. What is the ratio of the Gross enrolment ratio (%) of Trinidad and Tobago in 1990 to that in 2001?
Provide a short and direct response. 0.13. What is the ratio of the Gross enrolment ratio (%) of East Asia (developing only) in 1990 to that in 2003?
Give a very brief answer. 0.52. What is the ratio of the Gross enrolment ratio (%) of Sub-Saharan Africa (all income levels) in 1990 to that in 2003?
Ensure brevity in your answer.  0.71. What is the ratio of the Gross enrolment ratio (%) of Bulgaria in 1990 to that in 2003?
Provide a short and direct response. 0.91. What is the ratio of the Gross enrolment ratio (%) in Trinidad and Tobago in 1990 to that in 2003?
Your answer should be compact. 0.11. What is the ratio of the Gross enrolment ratio (%) in East Asia (developing only) in 1990 to that in 2004?
Ensure brevity in your answer.  0.49. What is the ratio of the Gross enrolment ratio (%) in Sub-Saharan Africa (all income levels) in 1990 to that in 2004?
Ensure brevity in your answer.  0.66. What is the ratio of the Gross enrolment ratio (%) in Bulgaria in 1990 to that in 2004?
Keep it short and to the point. 0.9. What is the ratio of the Gross enrolment ratio (%) of Trinidad and Tobago in 1990 to that in 2004?
Your response must be concise. 0.1. What is the ratio of the Gross enrolment ratio (%) of East Asia (developing only) in 1990 to that in 2005?
Provide a succinct answer. 0.46. What is the ratio of the Gross enrolment ratio (%) of Sub-Saharan Africa (all income levels) in 1990 to that in 2005?
Your answer should be compact. 0.62. What is the ratio of the Gross enrolment ratio (%) of Bulgaria in 1990 to that in 2005?
Your response must be concise. 0.87. What is the ratio of the Gross enrolment ratio (%) of Trinidad and Tobago in 1990 to that in 2005?
Make the answer very short. 0.09. What is the ratio of the Gross enrolment ratio (%) of East Asia (developing only) in 2000 to that in 2001?
Ensure brevity in your answer.  0.98. What is the ratio of the Gross enrolment ratio (%) in Sub-Saharan Africa (all income levels) in 2000 to that in 2001?
Give a very brief answer. 0.96. What is the ratio of the Gross enrolment ratio (%) in Bulgaria in 2000 to that in 2001?
Provide a short and direct response. 1. What is the ratio of the Gross enrolment ratio (%) in Trinidad and Tobago in 2000 to that in 2001?
Give a very brief answer. 0.96. What is the ratio of the Gross enrolment ratio (%) of East Asia (developing only) in 2000 to that in 2003?
Provide a succinct answer. 0.95. What is the ratio of the Gross enrolment ratio (%) in Sub-Saharan Africa (all income levels) in 2000 to that in 2003?
Your response must be concise. 0.81. What is the ratio of the Gross enrolment ratio (%) in Bulgaria in 2000 to that in 2003?
Your answer should be very brief. 0.93. What is the ratio of the Gross enrolment ratio (%) in Trinidad and Tobago in 2000 to that in 2003?
Give a very brief answer. 0.76. What is the ratio of the Gross enrolment ratio (%) of East Asia (developing only) in 2000 to that in 2004?
Offer a very short reply. 0.9. What is the ratio of the Gross enrolment ratio (%) in Sub-Saharan Africa (all income levels) in 2000 to that in 2004?
Your answer should be very brief. 0.74. What is the ratio of the Gross enrolment ratio (%) of Bulgaria in 2000 to that in 2004?
Your answer should be compact. 0.91. What is the ratio of the Gross enrolment ratio (%) of Trinidad and Tobago in 2000 to that in 2004?
Give a very brief answer. 0.7. What is the ratio of the Gross enrolment ratio (%) in East Asia (developing only) in 2000 to that in 2005?
Offer a terse response. 0.84. What is the ratio of the Gross enrolment ratio (%) of Sub-Saharan Africa (all income levels) in 2000 to that in 2005?
Your answer should be very brief. 0.7. What is the ratio of the Gross enrolment ratio (%) in Bulgaria in 2000 to that in 2005?
Your answer should be very brief. 0.89. What is the ratio of the Gross enrolment ratio (%) of Trinidad and Tobago in 2000 to that in 2005?
Provide a succinct answer. 0.69. What is the ratio of the Gross enrolment ratio (%) in East Asia (developing only) in 2001 to that in 2003?
Your answer should be very brief. 0.97. What is the ratio of the Gross enrolment ratio (%) of Sub-Saharan Africa (all income levels) in 2001 to that in 2003?
Your answer should be compact. 0.84. What is the ratio of the Gross enrolment ratio (%) of Bulgaria in 2001 to that in 2003?
Give a very brief answer. 0.93. What is the ratio of the Gross enrolment ratio (%) of Trinidad and Tobago in 2001 to that in 2003?
Ensure brevity in your answer.  0.8. What is the ratio of the Gross enrolment ratio (%) of East Asia (developing only) in 2001 to that in 2004?
Your answer should be compact. 0.92. What is the ratio of the Gross enrolment ratio (%) of Sub-Saharan Africa (all income levels) in 2001 to that in 2004?
Provide a succinct answer. 0.77. What is the ratio of the Gross enrolment ratio (%) in Bulgaria in 2001 to that in 2004?
Make the answer very short. 0.91. What is the ratio of the Gross enrolment ratio (%) of Trinidad and Tobago in 2001 to that in 2004?
Provide a short and direct response. 0.73. What is the ratio of the Gross enrolment ratio (%) in East Asia (developing only) in 2001 to that in 2005?
Give a very brief answer. 0.86. What is the ratio of the Gross enrolment ratio (%) of Sub-Saharan Africa (all income levels) in 2001 to that in 2005?
Your response must be concise. 0.73. What is the ratio of the Gross enrolment ratio (%) in Bulgaria in 2001 to that in 2005?
Your answer should be very brief. 0.89. What is the ratio of the Gross enrolment ratio (%) of Trinidad and Tobago in 2001 to that in 2005?
Give a very brief answer. 0.71. What is the ratio of the Gross enrolment ratio (%) of East Asia (developing only) in 2003 to that in 2004?
Offer a very short reply. 0.94. What is the ratio of the Gross enrolment ratio (%) of Sub-Saharan Africa (all income levels) in 2003 to that in 2004?
Your answer should be very brief. 0.92. What is the ratio of the Gross enrolment ratio (%) in Bulgaria in 2003 to that in 2004?
Your response must be concise. 0.98. What is the ratio of the Gross enrolment ratio (%) in Trinidad and Tobago in 2003 to that in 2004?
Provide a succinct answer. 0.92. What is the ratio of the Gross enrolment ratio (%) in East Asia (developing only) in 2003 to that in 2005?
Offer a very short reply. 0.89. What is the ratio of the Gross enrolment ratio (%) in Sub-Saharan Africa (all income levels) in 2003 to that in 2005?
Provide a succinct answer. 0.87. What is the ratio of the Gross enrolment ratio (%) of Bulgaria in 2003 to that in 2005?
Give a very brief answer. 0.95. What is the ratio of the Gross enrolment ratio (%) of Trinidad and Tobago in 2003 to that in 2005?
Provide a succinct answer. 0.9. What is the ratio of the Gross enrolment ratio (%) of East Asia (developing only) in 2004 to that in 2005?
Make the answer very short. 0.94. What is the ratio of the Gross enrolment ratio (%) in Sub-Saharan Africa (all income levels) in 2004 to that in 2005?
Provide a short and direct response. 0.95. What is the ratio of the Gross enrolment ratio (%) of Bulgaria in 2004 to that in 2005?
Your answer should be compact. 0.97. What is the ratio of the Gross enrolment ratio (%) of Trinidad and Tobago in 2004 to that in 2005?
Ensure brevity in your answer.  0.98. What is the difference between the highest and the second highest Gross enrolment ratio (%) in East Asia (developing only)?
Your answer should be very brief. 2.58. What is the difference between the highest and the second highest Gross enrolment ratio (%) in Sub-Saharan Africa (all income levels)?
Make the answer very short. 0.9. What is the difference between the highest and the second highest Gross enrolment ratio (%) of Bulgaria?
Provide a short and direct response. 2.35. What is the difference between the highest and the second highest Gross enrolment ratio (%) of Trinidad and Tobago?
Provide a succinct answer. 2.12. What is the difference between the highest and the lowest Gross enrolment ratio (%) in East Asia (developing only)?
Provide a short and direct response. 23.88. What is the difference between the highest and the lowest Gross enrolment ratio (%) of Sub-Saharan Africa (all income levels)?
Provide a succinct answer. 6.32. What is the difference between the highest and the lowest Gross enrolment ratio (%) of Bulgaria?
Your answer should be very brief. 10.34. What is the difference between the highest and the lowest Gross enrolment ratio (%) of Trinidad and Tobago?
Provide a short and direct response. 79.48. 